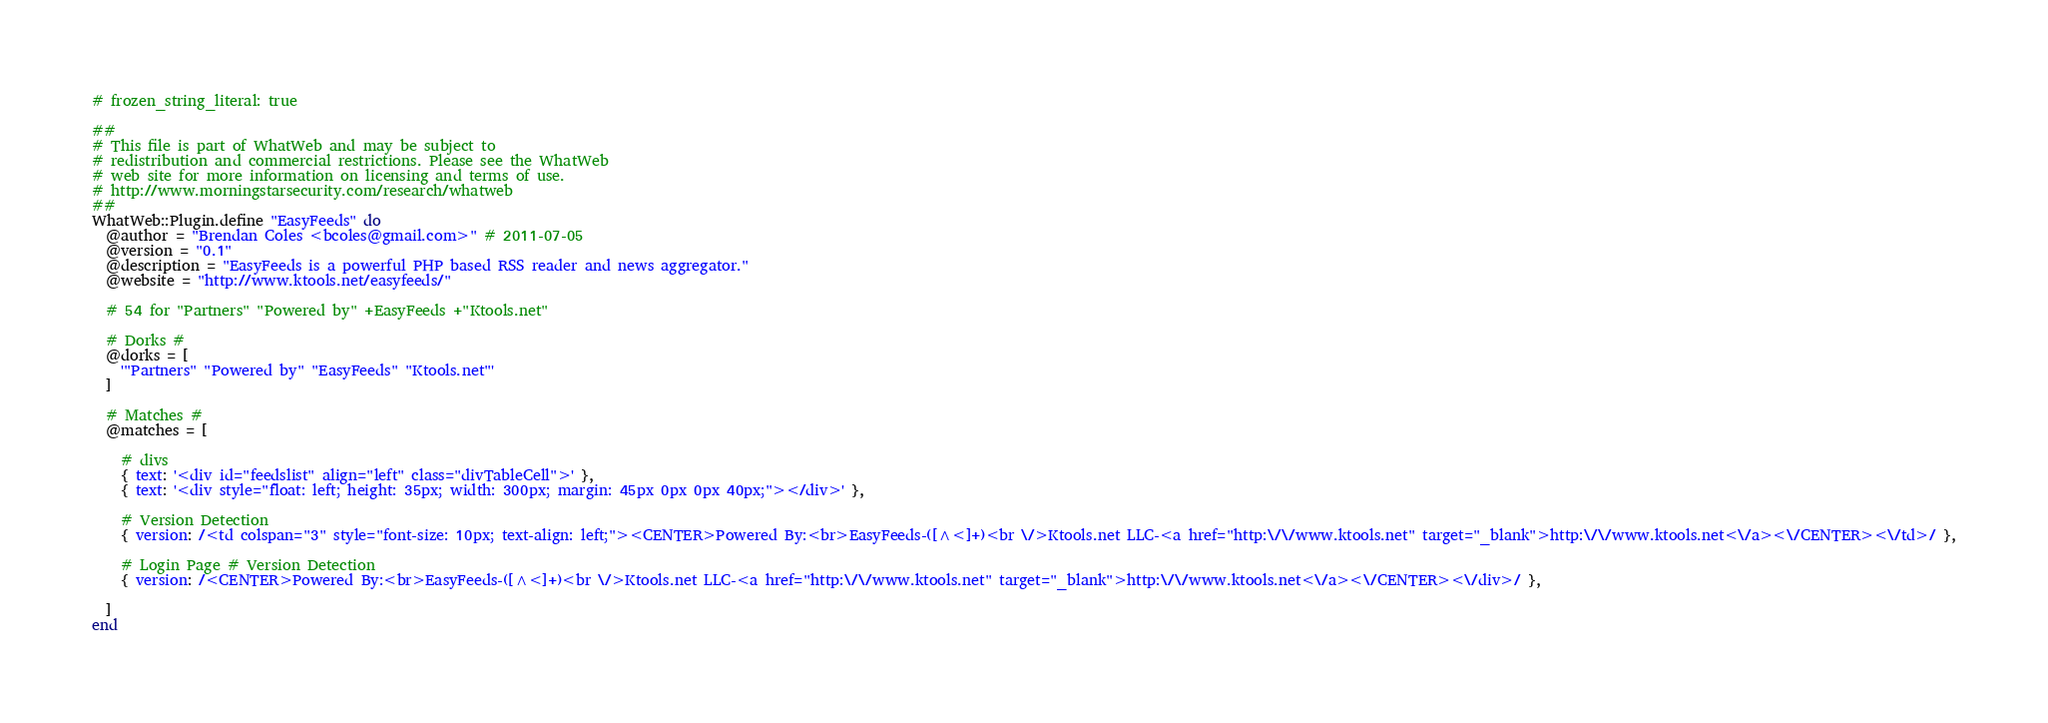<code> <loc_0><loc_0><loc_500><loc_500><_Ruby_># frozen_string_literal: true

##
# This file is part of WhatWeb and may be subject to
# redistribution and commercial restrictions. Please see the WhatWeb
# web site for more information on licensing and terms of use.
# http://www.morningstarsecurity.com/research/whatweb
##
WhatWeb::Plugin.define "EasyFeeds" do
  @author = "Brendan Coles <bcoles@gmail.com>" # 2011-07-05
  @version = "0.1"
  @description = "EasyFeeds is a powerful PHP based RSS reader and news aggregator."
  @website = "http://www.ktools.net/easyfeeds/"

  # 54 for "Partners" "Powered by" +EasyFeeds +"Ktools.net"

  # Dorks #
  @dorks = [
    '"Partners" "Powered by" "EasyFeeds" "Ktools.net"'
  ]

  # Matches #
  @matches = [

    # divs
    { text: '<div id="feedslist" align="left" class="divTableCell">' },
    { text: '<div style="float: left; height: 35px; width: 300px; margin: 45px 0px 0px 40px;"></div>' },

    # Version Detection
    { version: /<td colspan="3" style="font-size: 10px; text-align: left;"><CENTER>Powered By:<br>EasyFeeds-([^<]+)<br \/>Ktools.net LLC-<a href="http:\/\/www.ktools.net" target="_blank">http:\/\/www.ktools.net<\/a><\/CENTER><\/td>/ },

    # Login Page # Version Detection
    { version: /<CENTER>Powered By:<br>EasyFeeds-([^<]+)<br \/>Ktools.net LLC-<a href="http:\/\/www.ktools.net" target="_blank">http:\/\/www.ktools.net<\/a><\/CENTER><\/div>/ },

  ]
end
</code> 